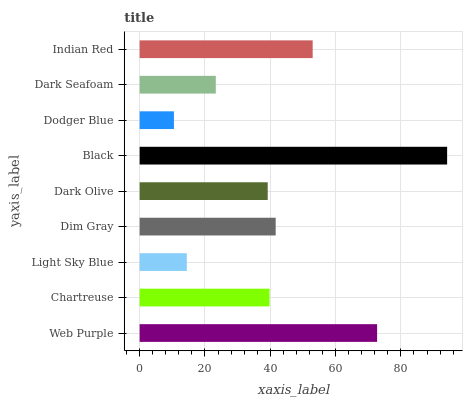Is Dodger Blue the minimum?
Answer yes or no. Yes. Is Black the maximum?
Answer yes or no. Yes. Is Chartreuse the minimum?
Answer yes or no. No. Is Chartreuse the maximum?
Answer yes or no. No. Is Web Purple greater than Chartreuse?
Answer yes or no. Yes. Is Chartreuse less than Web Purple?
Answer yes or no. Yes. Is Chartreuse greater than Web Purple?
Answer yes or no. No. Is Web Purple less than Chartreuse?
Answer yes or no. No. Is Chartreuse the high median?
Answer yes or no. Yes. Is Chartreuse the low median?
Answer yes or no. Yes. Is Dark Seafoam the high median?
Answer yes or no. No. Is Indian Red the low median?
Answer yes or no. No. 